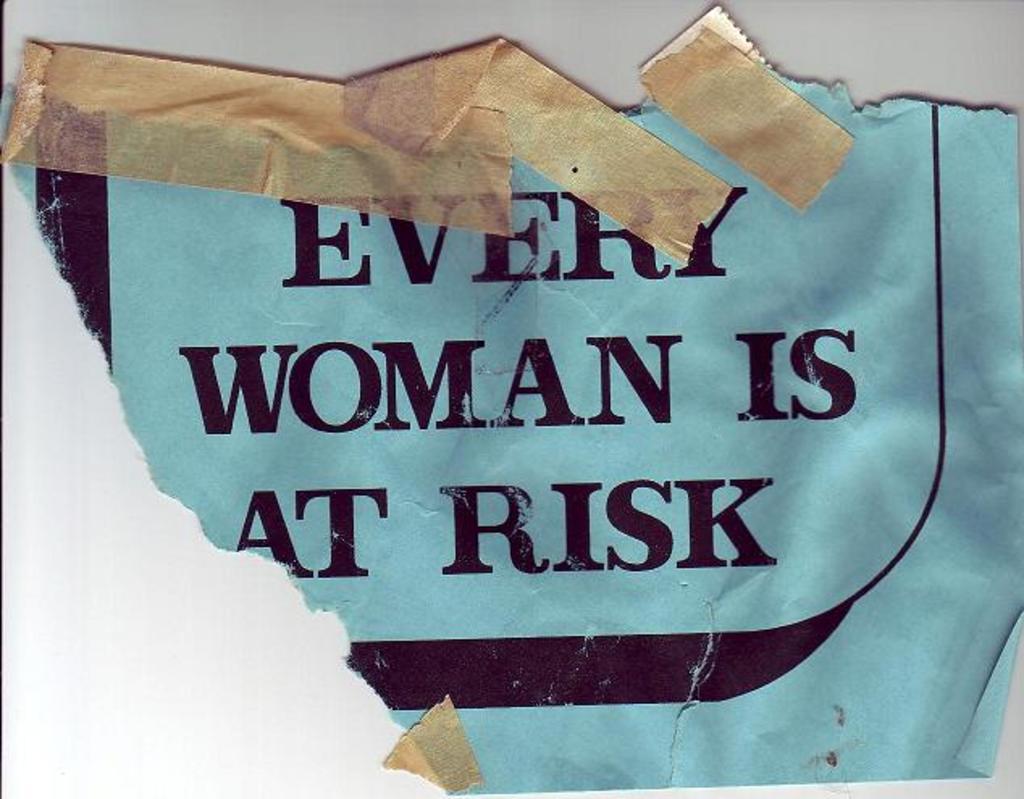Provide a one-sentence caption for the provided image. A torn piece of paper that is taped that reads "EVERY WOMAN IS AT RISK". 